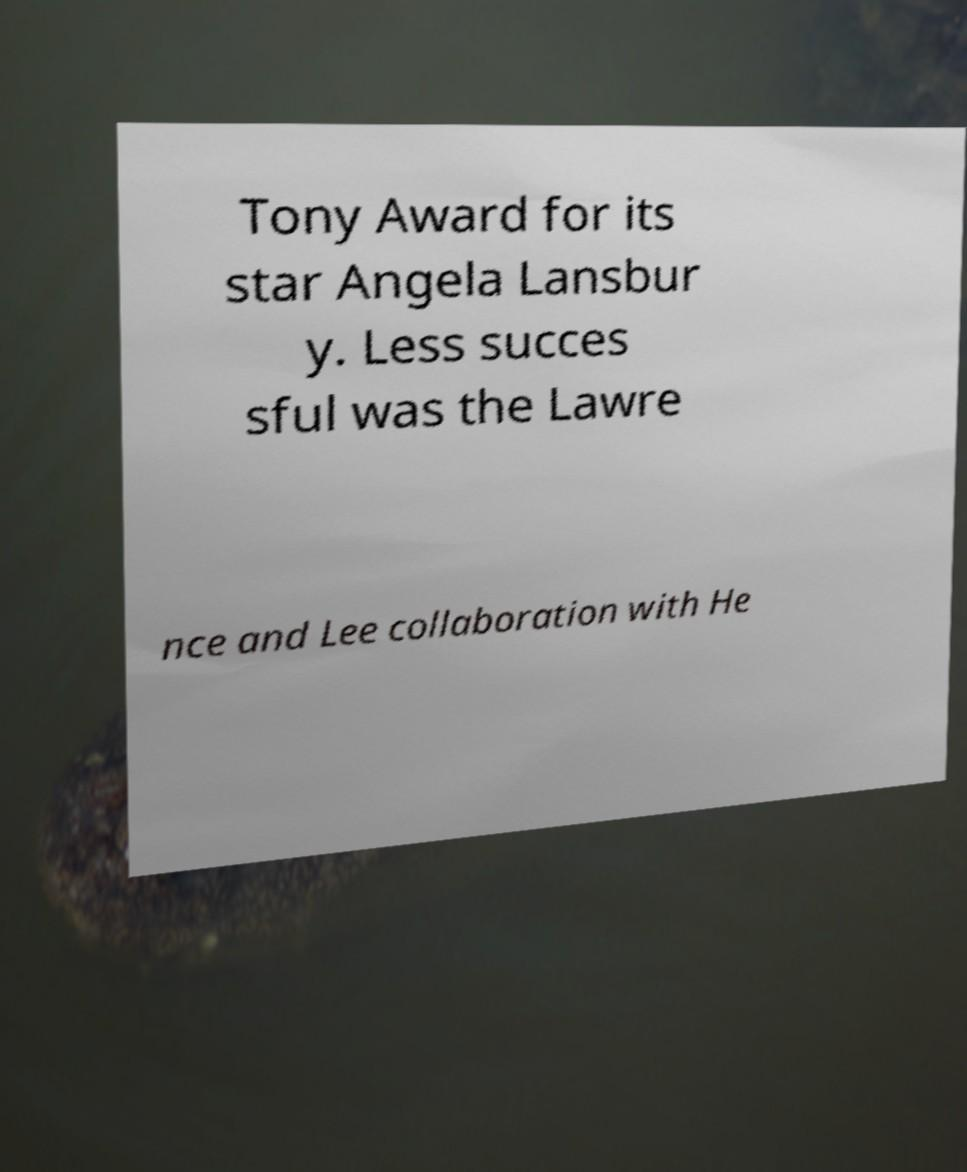Can you accurately transcribe the text from the provided image for me? Tony Award for its star Angela Lansbur y. Less succes sful was the Lawre nce and Lee collaboration with He 